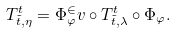<formula> <loc_0><loc_0><loc_500><loc_500>T ^ { t } _ { \tilde { t } , \eta } = \Phi _ { \varphi } ^ { \in } v \circ T ^ { t } _ { \tilde { t } , \lambda } \circ \Phi _ { \varphi } .</formula> 